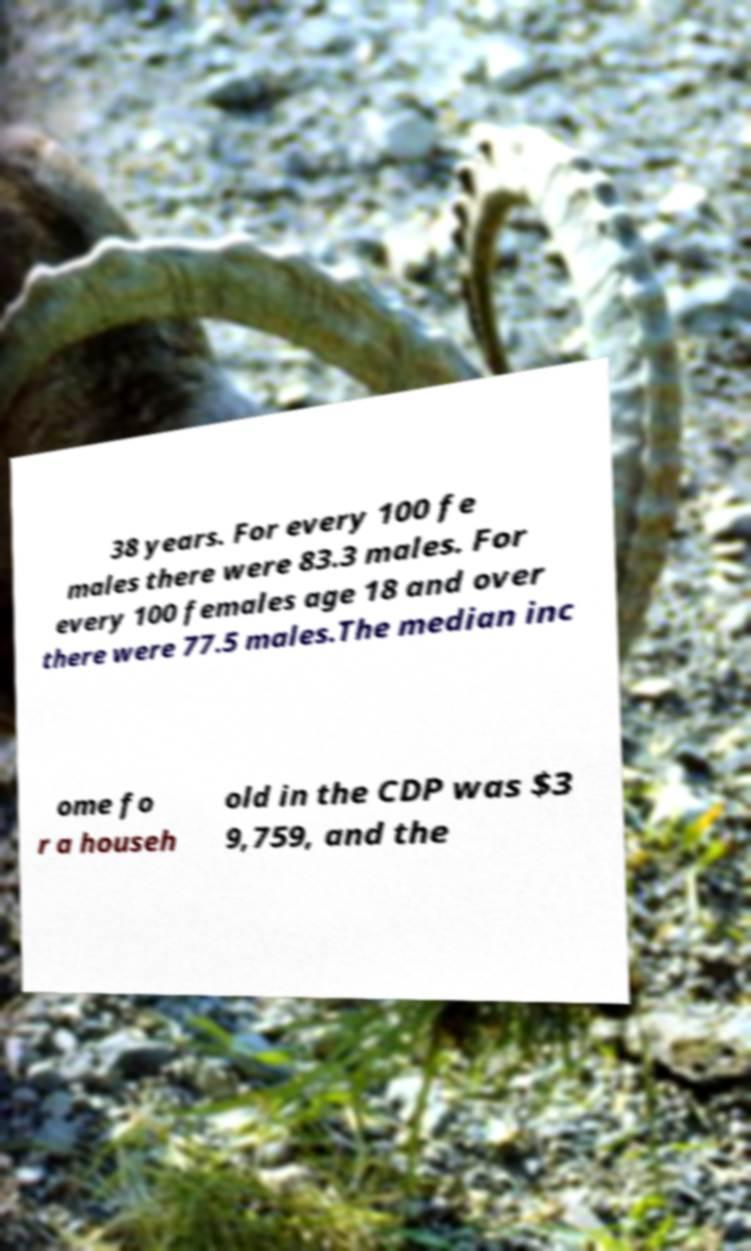For documentation purposes, I need the text within this image transcribed. Could you provide that? 38 years. For every 100 fe males there were 83.3 males. For every 100 females age 18 and over there were 77.5 males.The median inc ome fo r a househ old in the CDP was $3 9,759, and the 